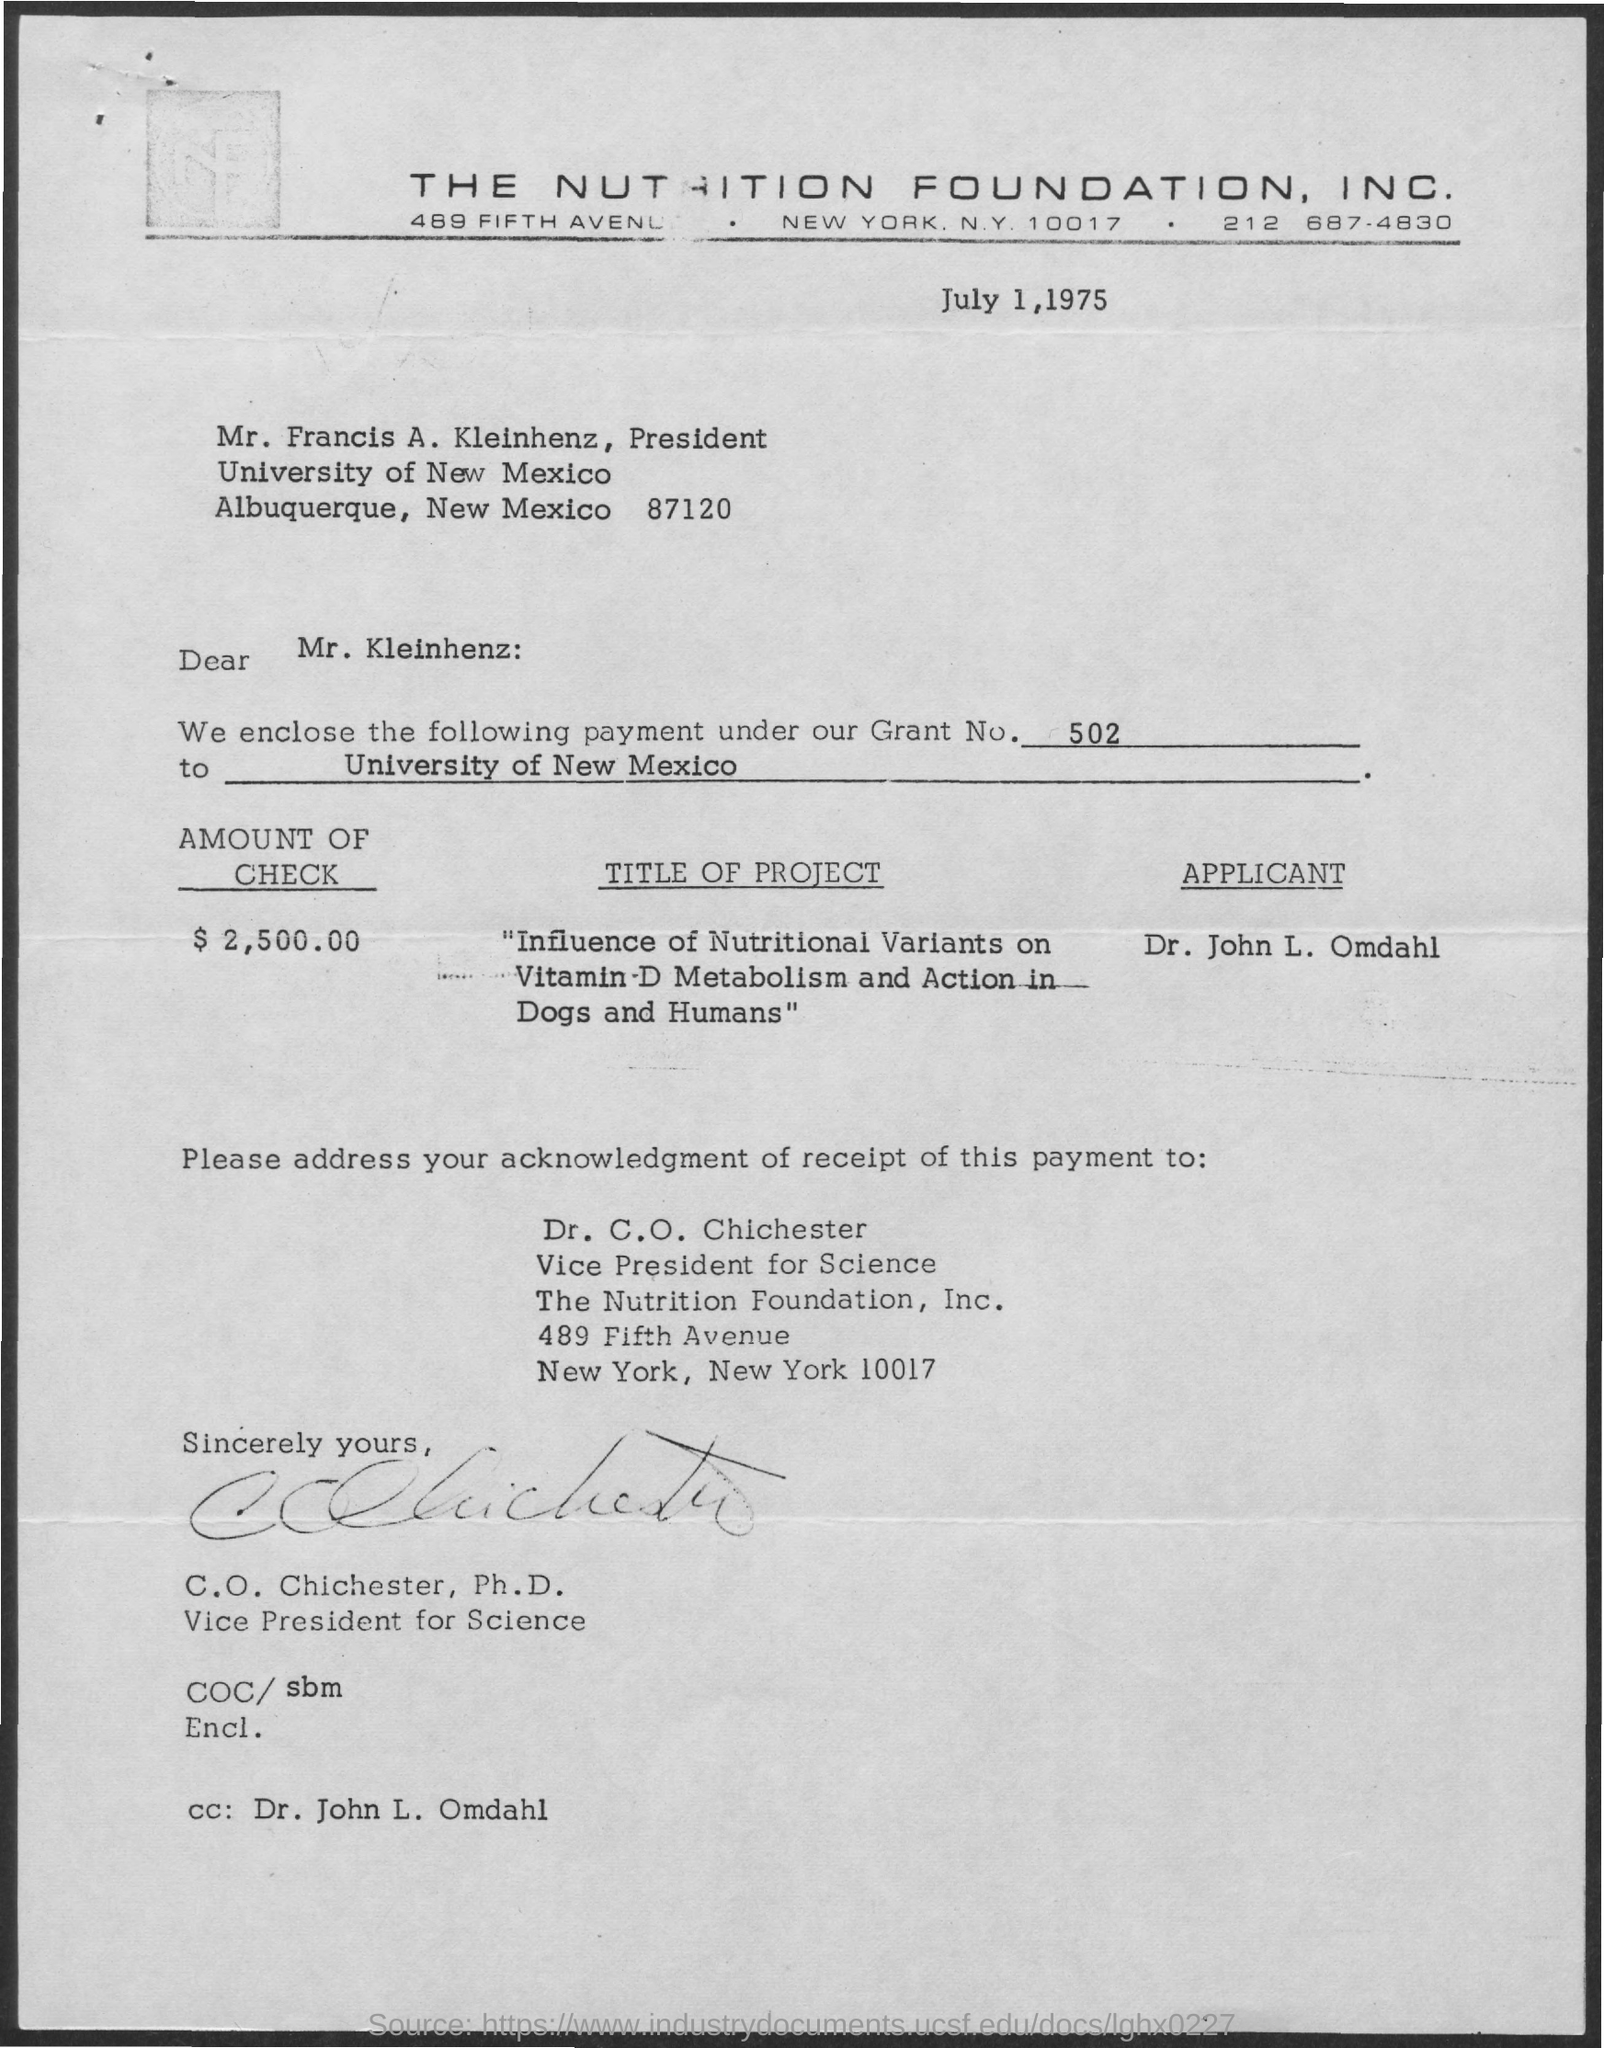Mention a couple of crucial points in this snapshot. The date mentioned in this document is July 1, 1975. The email cc list includes Dr. John L. Omdahl. The document states that the amount mentioned is $2,500.00. What is the grant number mentioned in this document? It is 502.. 